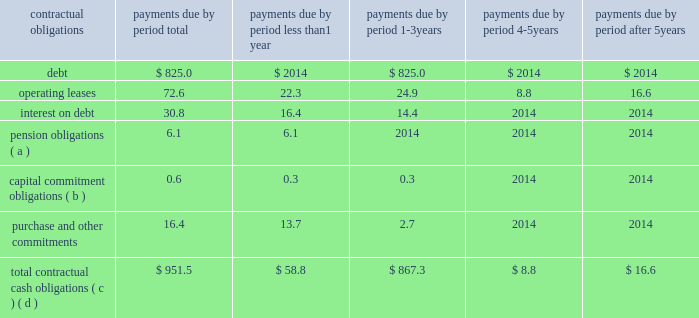Net cash flows provided by operating activities of $ 704.4 million for 2016 increased $ 154.7 million from 2015 due primarily to ( 1 ) improved operating performance and ( 2 ) lower supplier payments in 2016 compared to 2015 , partially offset by ( 1 ) the impact of excess tax benefits from stock plans , primarily due to our increased stock price , and ( 2 ) an increase in accounts receivable due to increased sales , primarily in the united states .
Net cash flows provided by operating activities of $ 549.7 million for 2015 decreased $ 472.6 million from 2014 due primarily to ( 1 ) the $ 750.0 million upfront payment received from medtronic under a litigation settlement agreement , and ( 2 ) a higher bonus payout in 2015 associated with 2014 performance .
These decreases were partially offset by ( 1 ) income tax payments of $ 224.5 million made in 2014 related to the medtronic settlement , ( 2 ) improved operating performance in 2015 , and ( 3 ) the $ 50.0 million charitable contribution made in 2014 to the edwards lifesciences foundation .
Net cash used in investing activities of $ 211.7 million in 2016 consisted primarily of capital expenditures of $ 176.1 million and $ 41.3 million for the acquisition of intangible assets .
Net cash used in investing activities of $ 316.1 million in 2015 consisted primarily of a $ 320.1 million net payment associated with the acquisition of cardiaq , and capital expenditures of $ 102.7 million , partially offset by net proceeds from investments of $ 119.6 million .
Net cash used in investing activities of $ 633.0 million in 2014 consisted primarily of net purchases of investments of $ 527.4 million and capital expenditures of $ 82.9 million .
Net cash used in financing activities of $ 268.5 million in 2016 consisted primarily of purchases of treasury stock of $ 662.3 million , partially offset by ( 1 ) net proceeds from the issuance of debt of $ 222.1 million , ( 2 ) proceeds from stock plans of $ 103.3 million , and ( 3 ) the excess tax benefit from stock plans of $ 64.3 million .
Net cash used in financing activities of $ 158.6 million in 2015 consisted primarily of purchases of treasury stock of $ 280.1 million , partially offset by ( 1 ) proceeds from stock plans of $ 87.2 million , and ( 2 ) the excess tax benefit from stock plans of $ 41.3 million .
Net cash used in financing activities of $ 153.0 million in 2014 consisted primarily of purchases of treasury stock of $ 300.9 million , partially offset by ( 1 ) proceeds from stock plans of $ 113.3 million , and ( 2 ) the excess tax benefit from stock plans of $ 49.4 million ( including the realization of previously unrealized excess tax benefits ) .
A summary of all of our contractual obligations and commercial commitments as of december 31 , 2016 were as follows ( in millions ) : .
( a ) the amount included in 2018 2018less than 1 year 2019 2019 reflects anticipated contributions to our various pension plans .
Anticipated contributions beyond one year are not determinable .
The total accrued benefit liability for our pension plans recognized as of december 31 , 2016 was $ 50.1 million .
This amount is impacted .
What percentage of total contractual cash obligations is operating leases? 
Computations: (72.6 / 951.5)
Answer: 0.0763. 